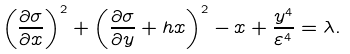<formula> <loc_0><loc_0><loc_500><loc_500>\left ( \frac { \partial \sigma } { \partial x } \right ) ^ { 2 } + \left ( \frac { \partial \sigma } { \partial y } + h x \right ) ^ { 2 } - x + \frac { y ^ { 4 } } { \varepsilon ^ { 4 } } = \lambda .</formula> 